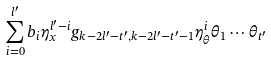Convert formula to latex. <formula><loc_0><loc_0><loc_500><loc_500>\sum _ { i = 0 } ^ { l ^ { \prime } } b _ { i } \eta _ { x } ^ { l ^ { \prime } - i } g _ { k - 2 l ^ { \prime } - t ^ { \prime } , k - 2 l ^ { \prime } - t ^ { \prime } - 1 } \eta _ { \theta } ^ { i } \theta _ { 1 } \cdots \theta _ { t ^ { \prime } }</formula> 